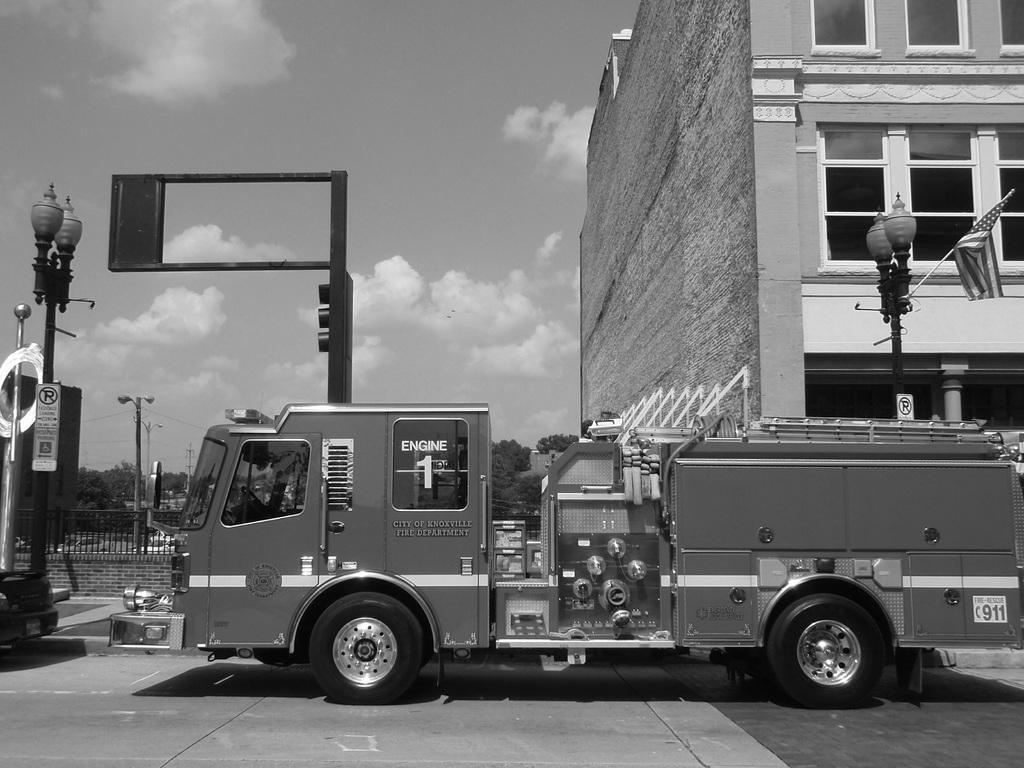In one or two sentences, can you explain what this image depicts? In this image I see a truck over here and I see few poles and I see a flag over here and I see the road. In the background I see the fencing over here and I see the trees, sky and the building and I see few sign boards on the poles and I see that this is a black and white image. 